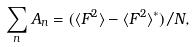Convert formula to latex. <formula><loc_0><loc_0><loc_500><loc_500>\sum _ { n } A _ { n } = ( \langle F ^ { 2 } \rangle - \langle F ^ { 2 } \rangle ^ { * } ) / N ,</formula> 